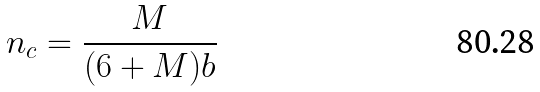<formula> <loc_0><loc_0><loc_500><loc_500>n _ { c } = \frac { M } { ( 6 + M ) b }</formula> 